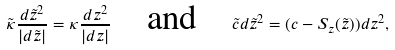Convert formula to latex. <formula><loc_0><loc_0><loc_500><loc_500>\tilde { \kappa } \frac { d \tilde { z } ^ { 2 } } { | d \tilde { z } | } = \kappa \frac { d z ^ { 2 } } { | d z | } \text {\quad and\quad} \tilde { c } d \tilde { z } ^ { 2 } = ( c - S _ { z } ( \tilde { z } ) ) d z ^ { 2 } ,</formula> 